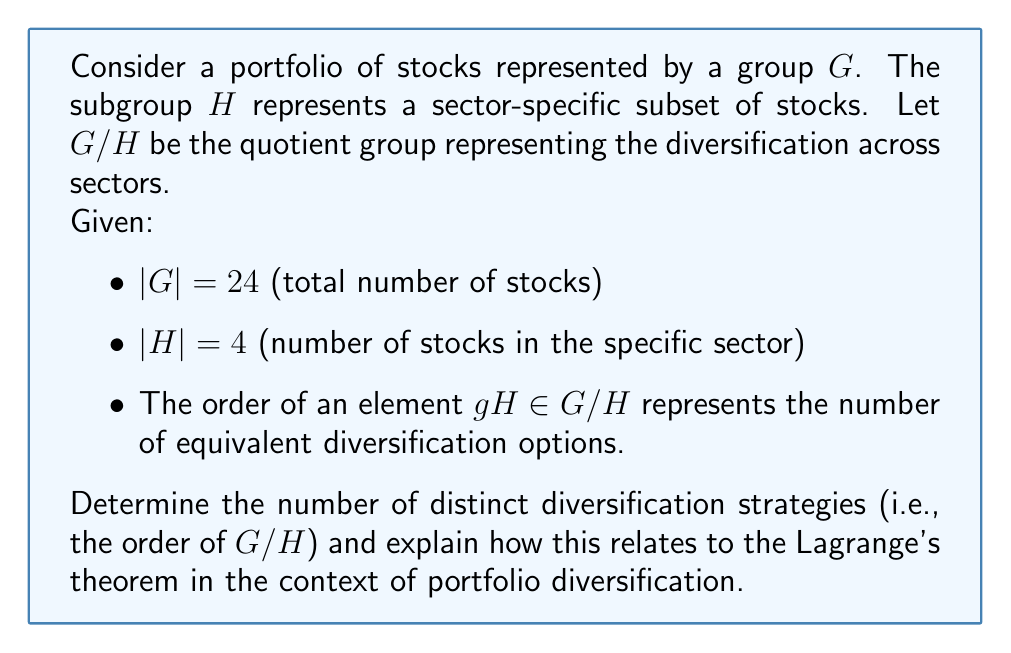What is the answer to this math problem? Let's approach this step-by-step:

1) First, recall Lagrange's Theorem: For a finite group $G$ and a subgroup $H$ of $G$, the order of the quotient group $G/H$ is equal to the index of $H$ in $G$. Mathematically:

   $$|G/H| = [G:H] = \frac{|G|}{|H|}$$

2) In our case:
   $|G| = 24$ (total number of stocks)
   $|H| = 4$ (number of stocks in the specific sector)

3) Applying Lagrange's Theorem:

   $$|G/H| = \frac{|G|}{|H|} = \frac{24}{4} = 6$$

4) Interpretation in the context of portfolio diversification:
   - The order of $G/H$ (which is 6) represents the number of distinct diversification strategies available.
   - Each element $gH$ in $G/H$ represents a coset, which in this context can be interpreted as a group of equivalent diversification options.
   - The fact that $|G/H| = 6$ means there are 6 distinct ways to diversify the portfolio across sectors, given the specific sector represented by $H$.

5) This demonstrates how Lagrange's Theorem and quotient groups can be applied to understand the structure of diversification options in a portfolio:
   - The total number of stocks ($|G|$) divided by the number of stocks in a specific sector ($|H|$) gives us the number of distinct sector-based diversification strategies.
   - Each strategy (element of $G/H$) represents a way of allocating investments across sectors while treating stocks within the same sector (coset) as equivalent for diversification purposes.
Answer: 6 distinct diversification strategies 